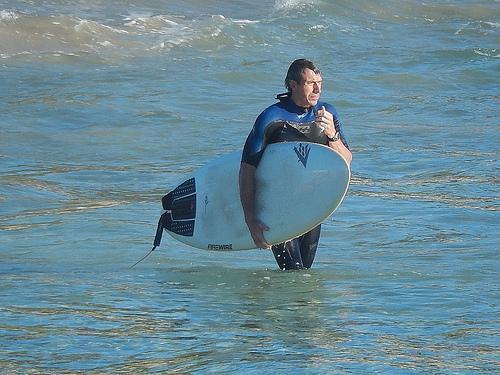How many people are in the picture?
Give a very brief answer. 1. 